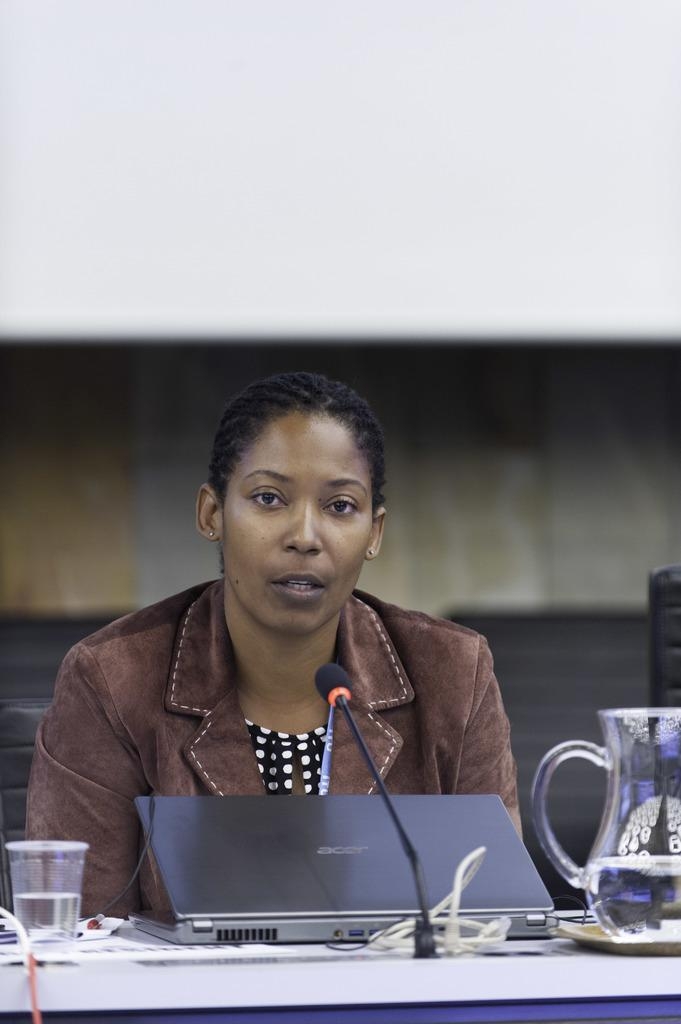What is the woman doing in the image? The woman is sitting on a chair in the image. What is in front of the woman? There is a table in front of the woman. What objects are on the table? There is a laptop, a glass, a water jar, and a mic on the table. What type of ring is the woman wearing on her finger in the image? There is no ring visible on the woman's finger in the image. What degree does the woman have, as shown in the image? The image does not provide any information about the woman's degree. Is the earth visible in the image? The image does not show the earth; it is a close-up of a woman sitting at a table with various objects. 